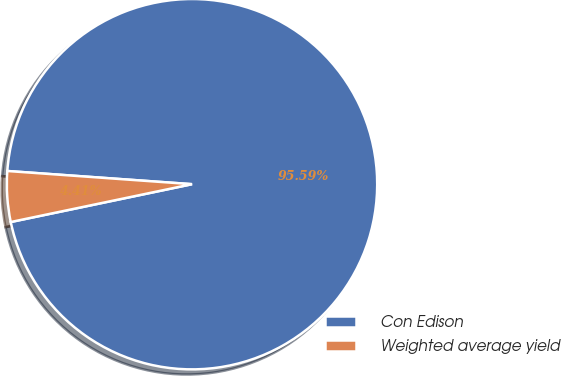Convert chart. <chart><loc_0><loc_0><loc_500><loc_500><pie_chart><fcel>Con Edison<fcel>Weighted average yield<nl><fcel>95.59%<fcel>4.41%<nl></chart> 